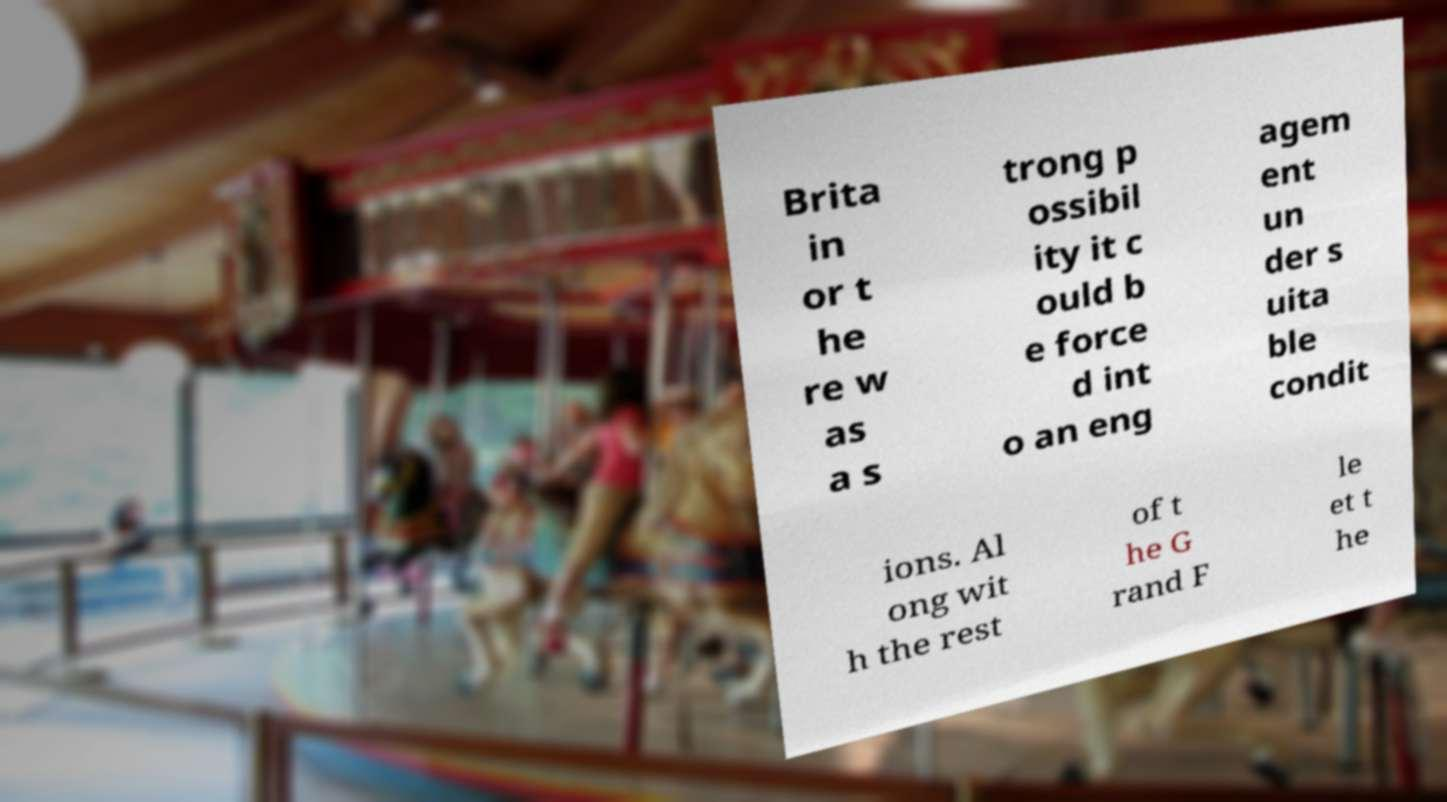Please read and relay the text visible in this image. What does it say? Brita in or t he re w as a s trong p ossibil ity it c ould b e force d int o an eng agem ent un der s uita ble condit ions. Al ong wit h the rest of t he G rand F le et t he 